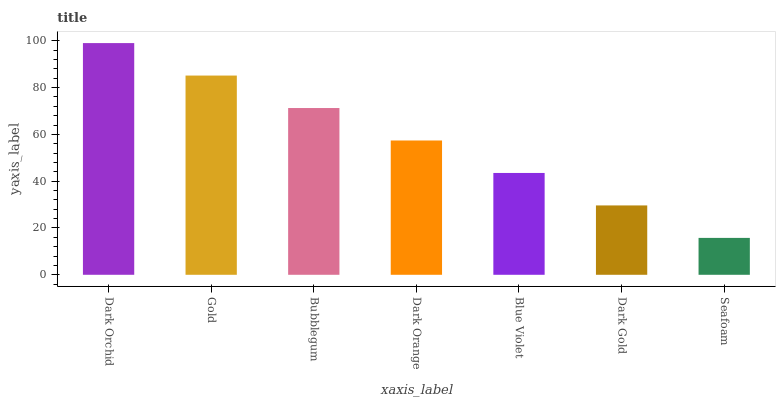Is Gold the minimum?
Answer yes or no. No. Is Gold the maximum?
Answer yes or no. No. Is Dark Orchid greater than Gold?
Answer yes or no. Yes. Is Gold less than Dark Orchid?
Answer yes or no. Yes. Is Gold greater than Dark Orchid?
Answer yes or no. No. Is Dark Orchid less than Gold?
Answer yes or no. No. Is Dark Orange the high median?
Answer yes or no. Yes. Is Dark Orange the low median?
Answer yes or no. Yes. Is Bubblegum the high median?
Answer yes or no. No. Is Seafoam the low median?
Answer yes or no. No. 